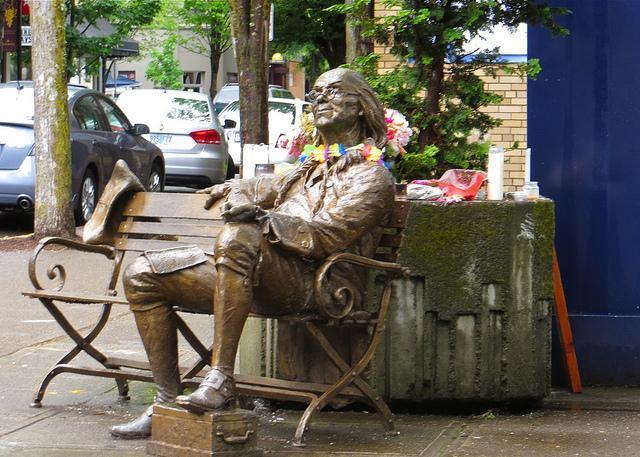How many cars are there?
Give a very brief answer. 3. 